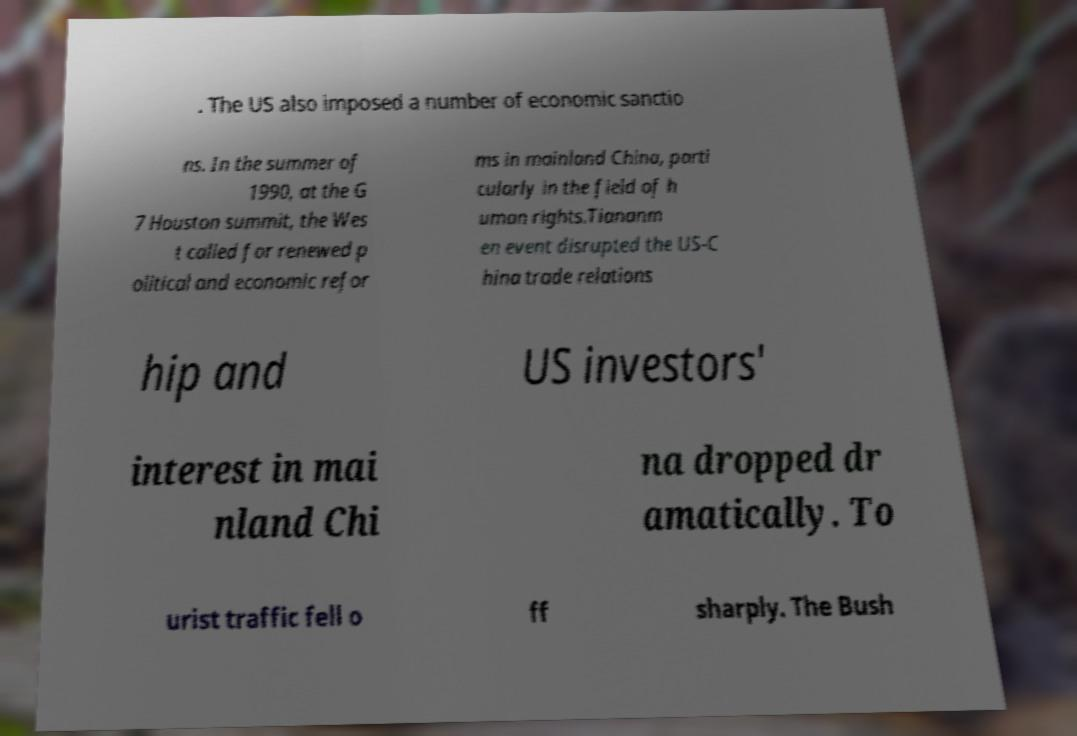Can you read and provide the text displayed in the image?This photo seems to have some interesting text. Can you extract and type it out for me? . The US also imposed a number of economic sanctio ns. In the summer of 1990, at the G 7 Houston summit, the Wes t called for renewed p olitical and economic refor ms in mainland China, parti cularly in the field of h uman rights.Tiananm en event disrupted the US-C hina trade relations hip and US investors' interest in mai nland Chi na dropped dr amatically. To urist traffic fell o ff sharply. The Bush 